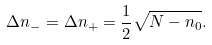Convert formula to latex. <formula><loc_0><loc_0><loc_500><loc_500>\Delta n _ { - } = \Delta n _ { + } = \frac { 1 } { 2 } \sqrt { N - n _ { 0 } } .</formula> 